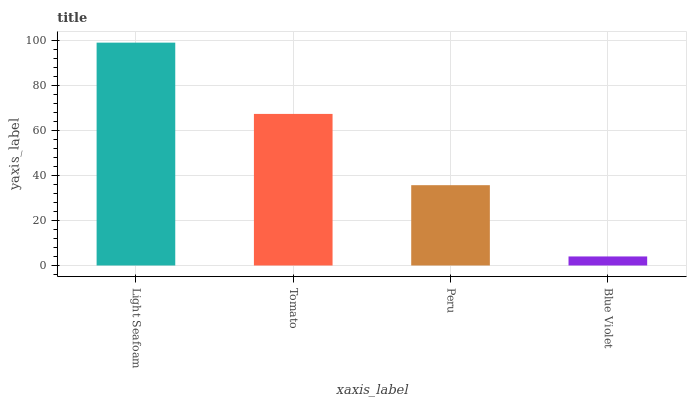Is Blue Violet the minimum?
Answer yes or no. Yes. Is Light Seafoam the maximum?
Answer yes or no. Yes. Is Tomato the minimum?
Answer yes or no. No. Is Tomato the maximum?
Answer yes or no. No. Is Light Seafoam greater than Tomato?
Answer yes or no. Yes. Is Tomato less than Light Seafoam?
Answer yes or no. Yes. Is Tomato greater than Light Seafoam?
Answer yes or no. No. Is Light Seafoam less than Tomato?
Answer yes or no. No. Is Tomato the high median?
Answer yes or no. Yes. Is Peru the low median?
Answer yes or no. Yes. Is Blue Violet the high median?
Answer yes or no. No. Is Light Seafoam the low median?
Answer yes or no. No. 